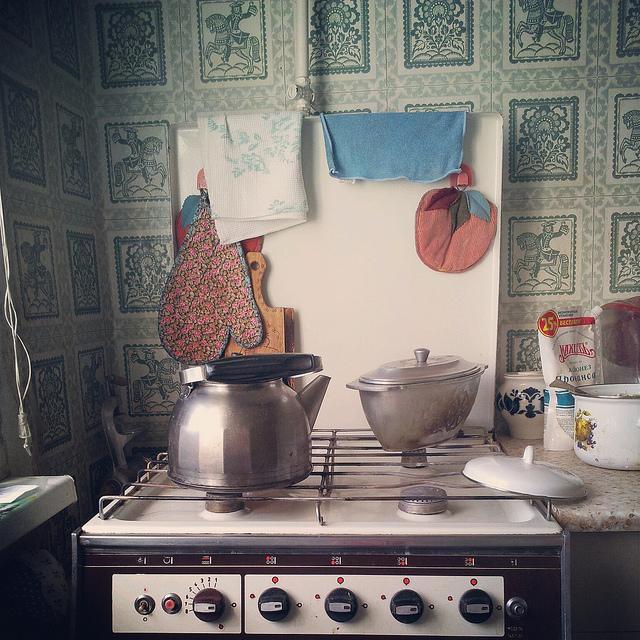What room is this?
Be succinct. Kitchen. Are all the burners on?
Give a very brief answer. No. Would a person cook here?
Answer briefly. Yes. How many pins are on the stove?
Keep it brief. 0. What cooking items are on the stove?
Concise answer only. Tea pot. 